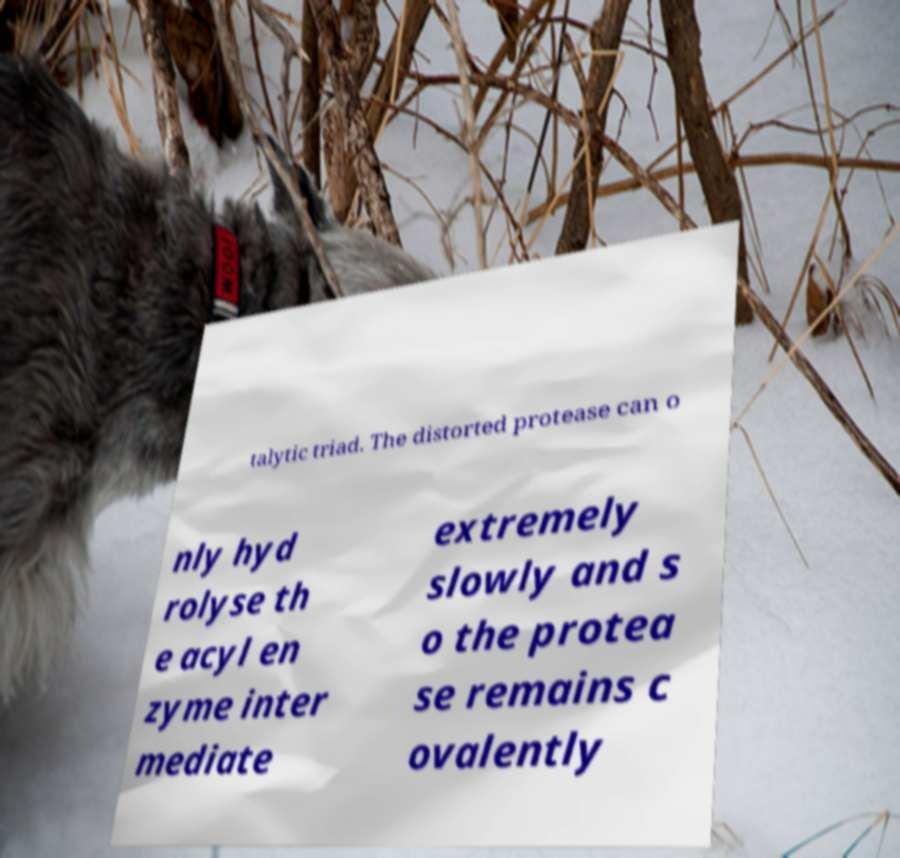I need the written content from this picture converted into text. Can you do that? talytic triad. The distorted protease can o nly hyd rolyse th e acyl en zyme inter mediate extremely slowly and s o the protea se remains c ovalently 